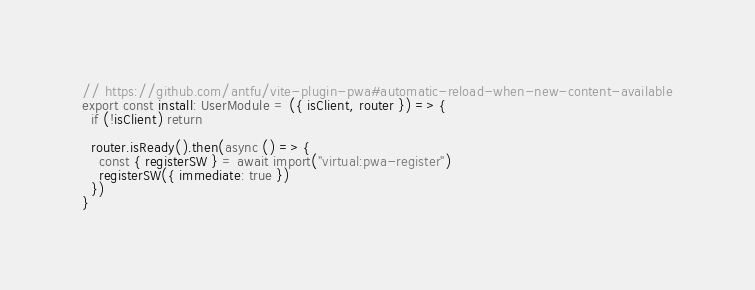<code> <loc_0><loc_0><loc_500><loc_500><_TypeScript_>// https://github.com/antfu/vite-plugin-pwa#automatic-reload-when-new-content-available
export const install: UserModule = ({ isClient, router }) => {
  if (!isClient) return

  router.isReady().then(async () => {
    const { registerSW } = await import("virtual:pwa-register")
    registerSW({ immediate: true })
  })
}
</code> 